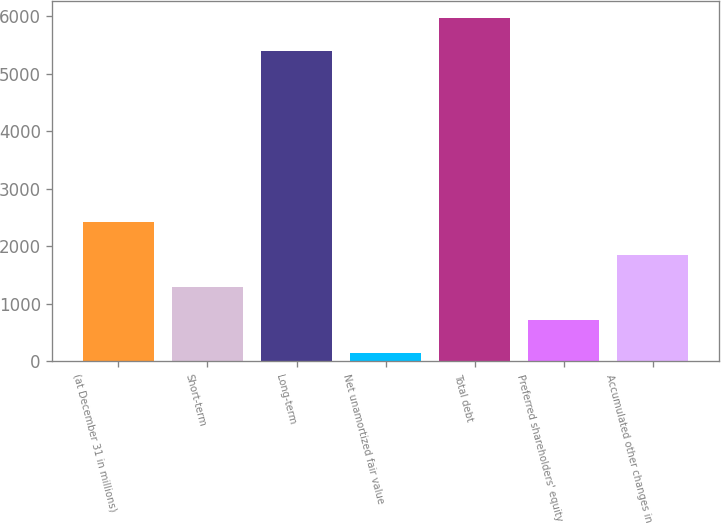<chart> <loc_0><loc_0><loc_500><loc_500><bar_chart><fcel>(at December 31 in millions)<fcel>Short-term<fcel>Long-term<fcel>Net unamortized fair value<fcel>Total debt<fcel>Preferred shareholders' equity<fcel>Accumulated other changes in<nl><fcel>2428.2<fcel>1287.6<fcel>5393<fcel>147<fcel>5963.3<fcel>717.3<fcel>1857.9<nl></chart> 